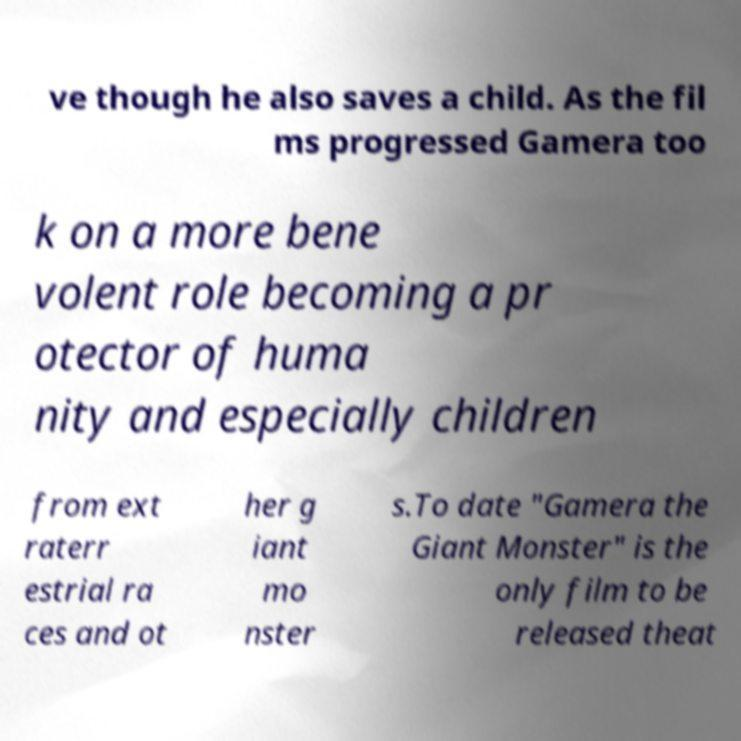For documentation purposes, I need the text within this image transcribed. Could you provide that? ve though he also saves a child. As the fil ms progressed Gamera too k on a more bene volent role becoming a pr otector of huma nity and especially children from ext raterr estrial ra ces and ot her g iant mo nster s.To date "Gamera the Giant Monster" is the only film to be released theat 